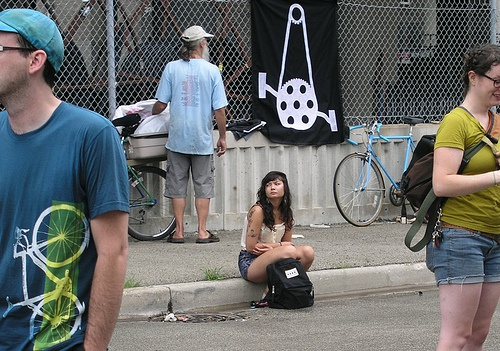Describe the objects in this image and their specific colors. I can see people in black, blue, gray, and darkblue tones, people in black, gray, olive, and darkgray tones, people in black, gray, lightblue, and darkgray tones, people in black, darkgray, gray, and tan tones, and bicycle in black, darkgray, and gray tones in this image. 